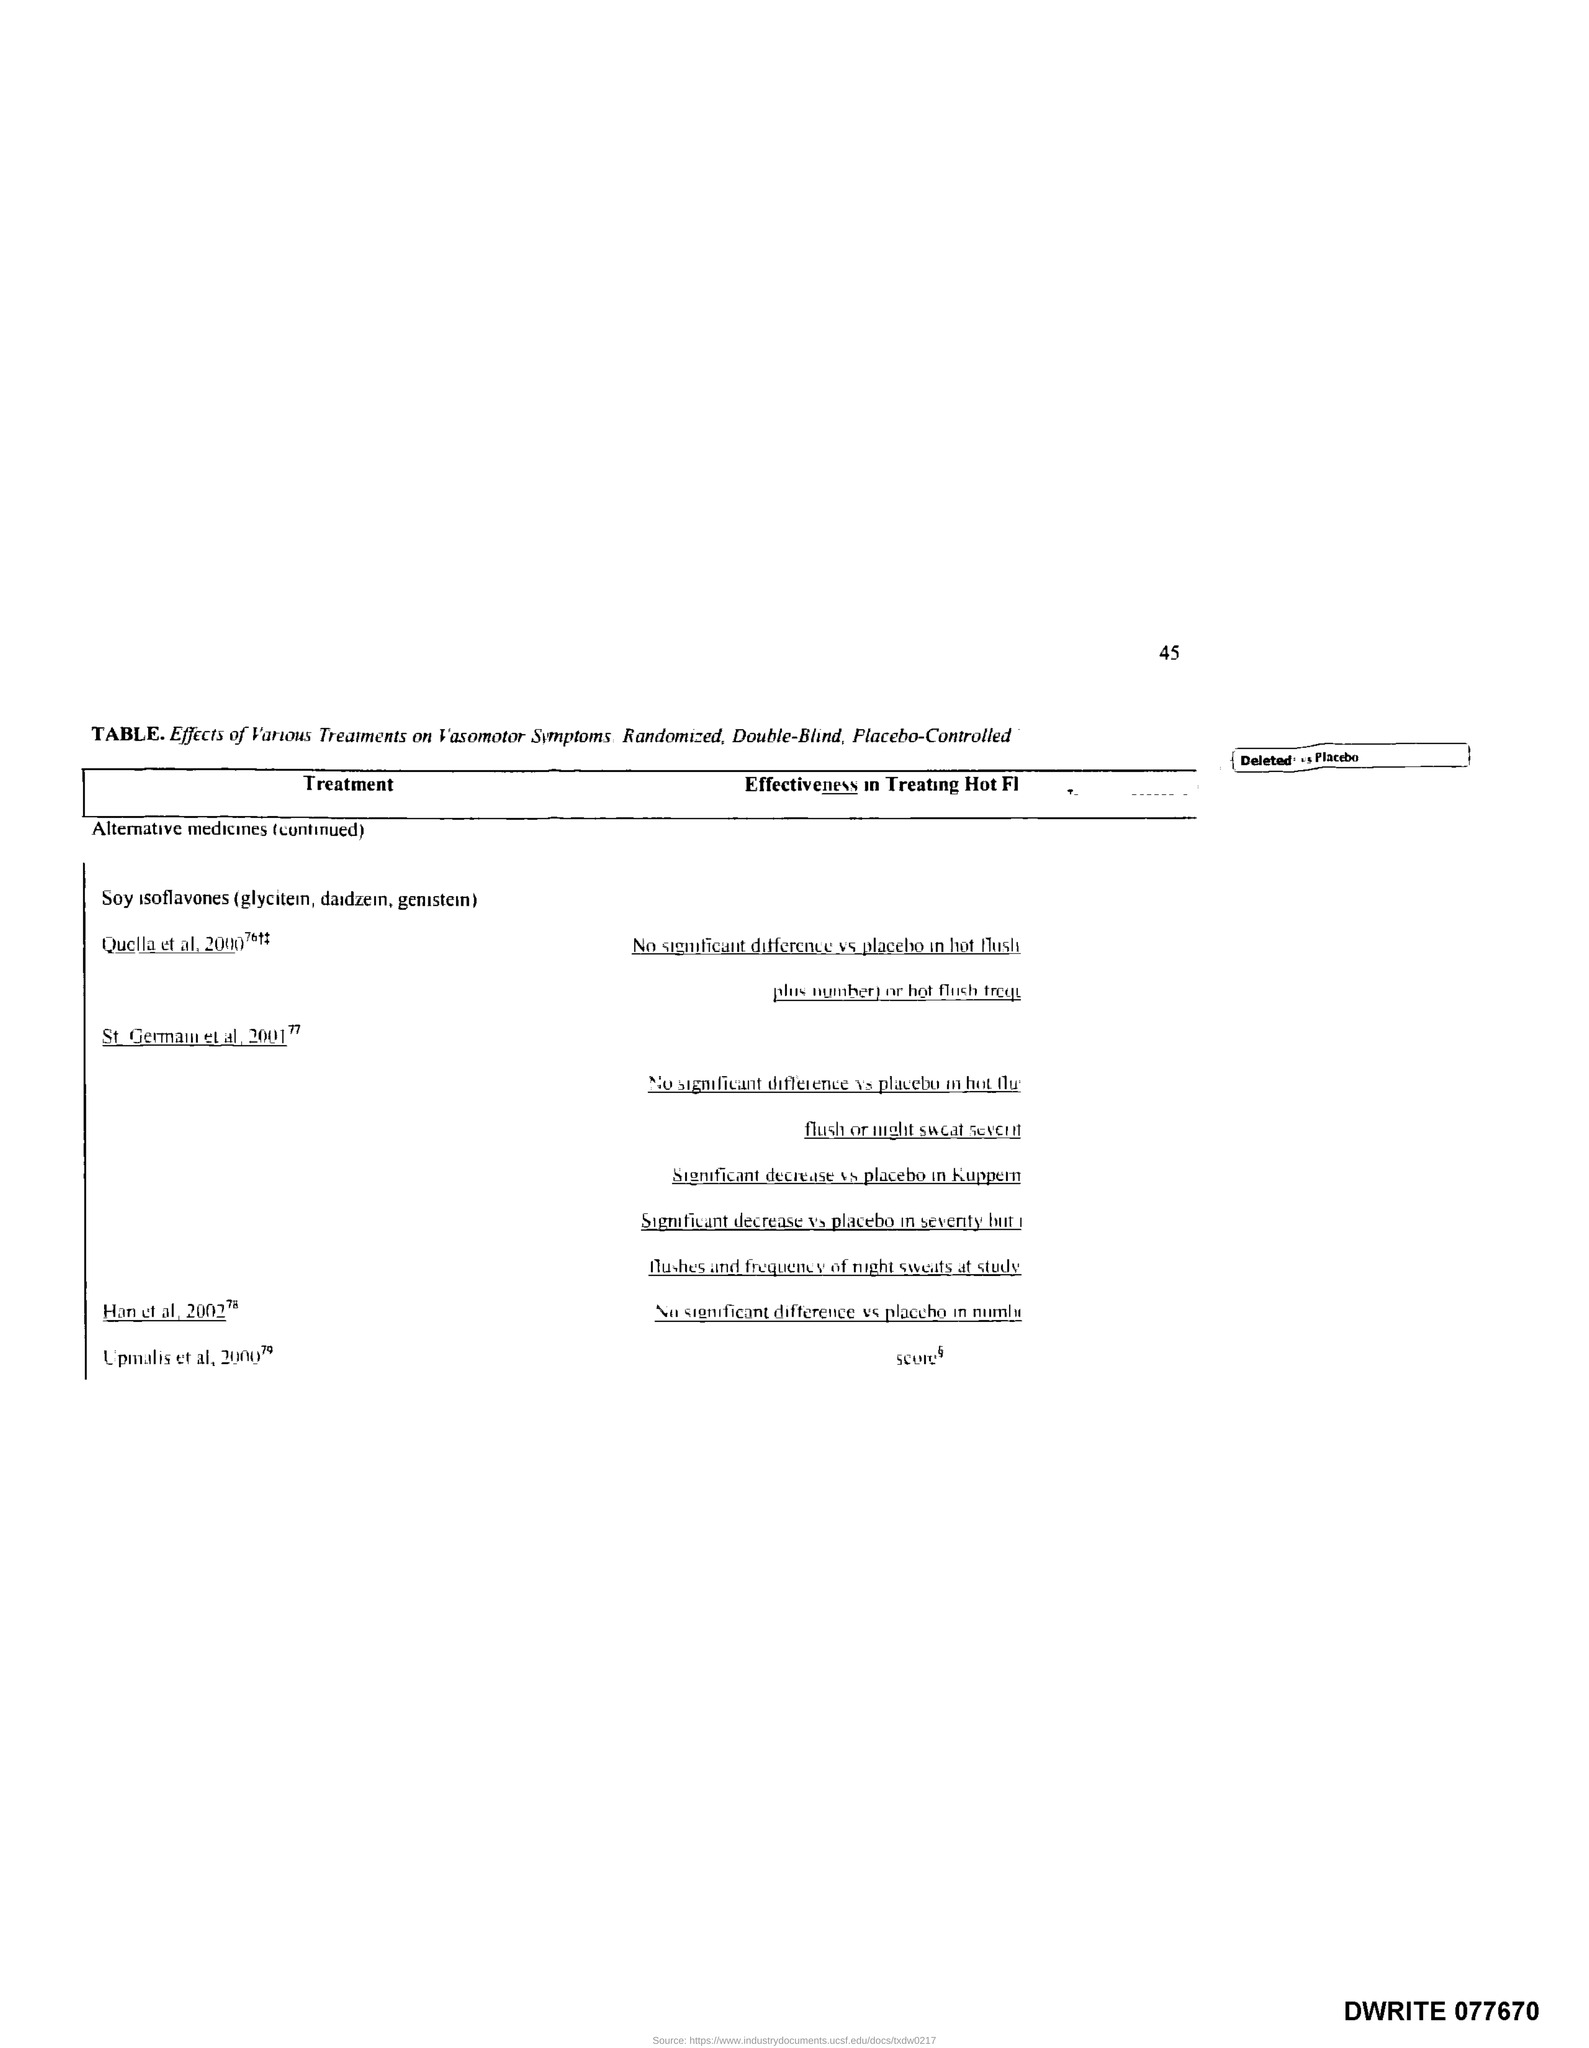Outline some significant characteristics in this image. The page number is 45. The title of the first column of the table is 'Treatment.' 